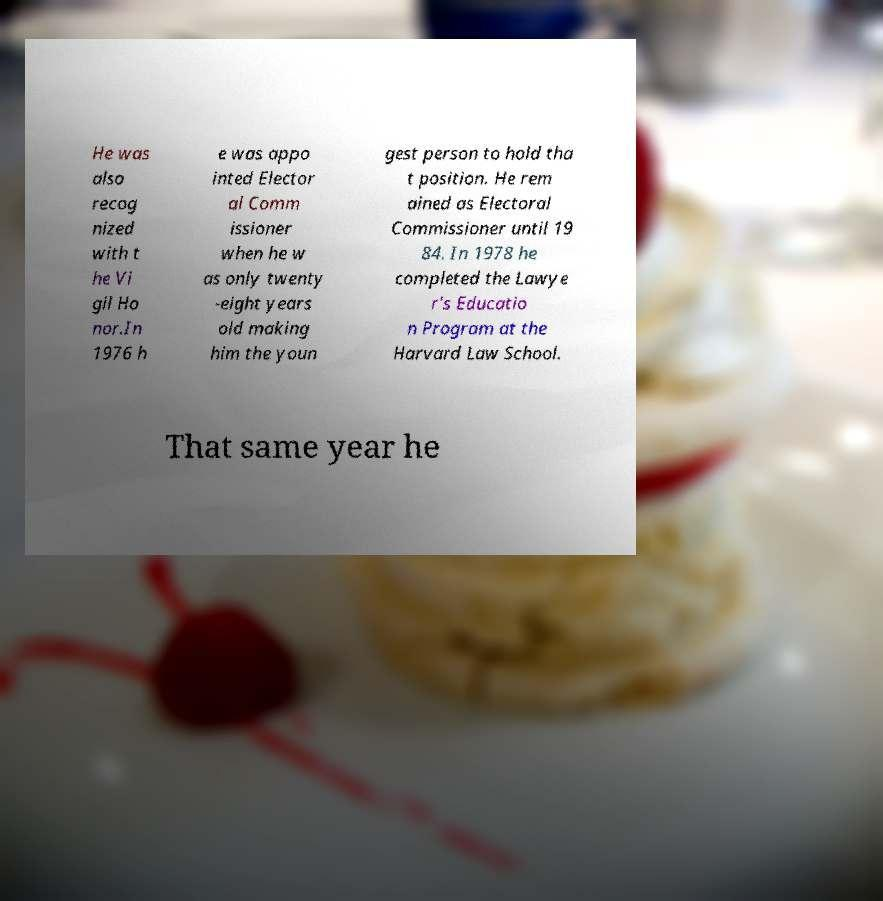Can you accurately transcribe the text from the provided image for me? He was also recog nized with t he Vi gil Ho nor.In 1976 h e was appo inted Elector al Comm issioner when he w as only twenty -eight years old making him the youn gest person to hold tha t position. He rem ained as Electoral Commissioner until 19 84. In 1978 he completed the Lawye r's Educatio n Program at the Harvard Law School. That same year he 